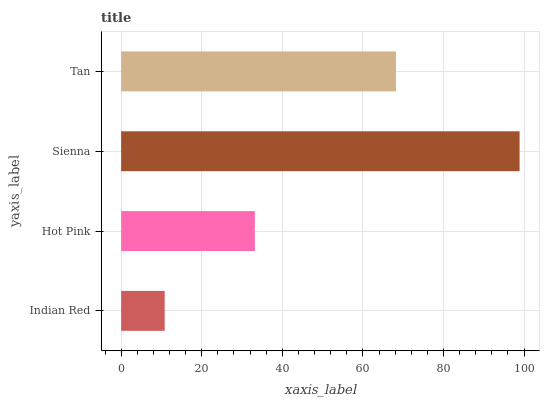Is Indian Red the minimum?
Answer yes or no. Yes. Is Sienna the maximum?
Answer yes or no. Yes. Is Hot Pink the minimum?
Answer yes or no. No. Is Hot Pink the maximum?
Answer yes or no. No. Is Hot Pink greater than Indian Red?
Answer yes or no. Yes. Is Indian Red less than Hot Pink?
Answer yes or no. Yes. Is Indian Red greater than Hot Pink?
Answer yes or no. No. Is Hot Pink less than Indian Red?
Answer yes or no. No. Is Tan the high median?
Answer yes or no. Yes. Is Hot Pink the low median?
Answer yes or no. Yes. Is Indian Red the high median?
Answer yes or no. No. Is Indian Red the low median?
Answer yes or no. No. 